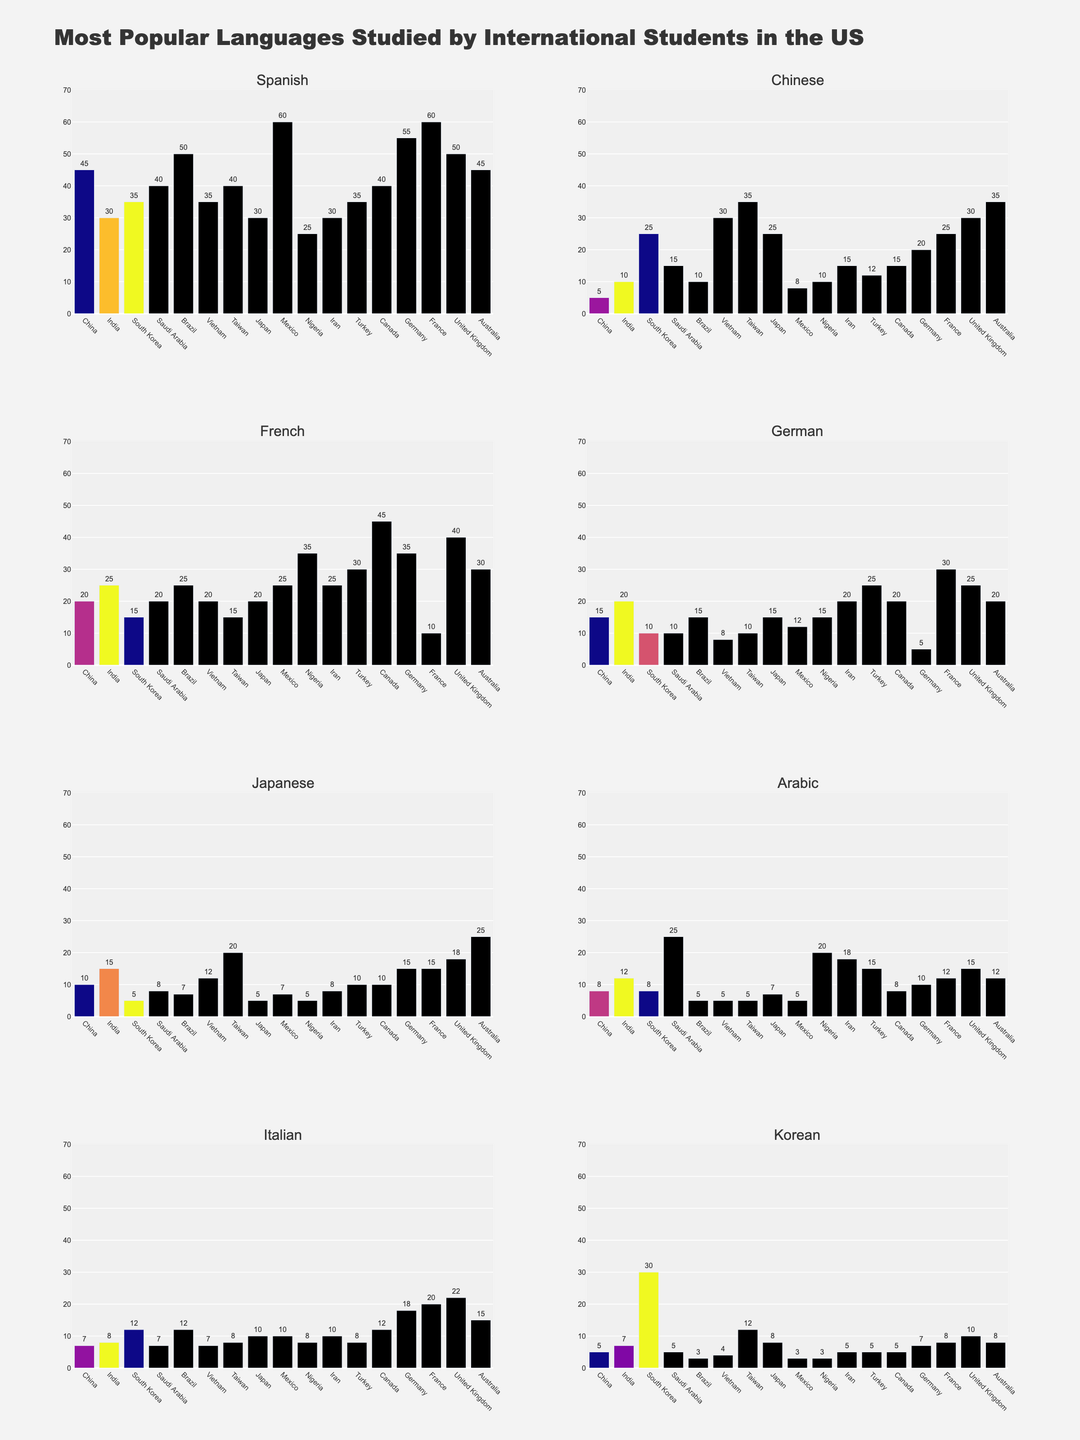Which country has the highest number of students studying Spanish? By comparing the heights of the bars in the Spanish subplot, we see that Mexico has the tallest bar.
Answer: Mexico How many more students in Taiwan study Chinese compared to Germany? Taiwan has 35 students studying Chinese, while Germany has 20. The difference is 35 - 20 = 15.
Answer: 15 Which country has the lowest number of students studying Italian? By comparing all the bars in the Italian subplot, we see that Vietnam and Mexico have the shortest bars, both with 7 students.
Answer: Vietnam, Mexico What is the total number of students studying French in Brazil, Iran, and Canada combined? Summing the French students in these countries gives us 25 (Brazil) + 25 (Iran) + 45 (Canada) = 95.
Answer: 95 Are there more students studying Arabic in Saudi Arabia or Chinese in South Korea? Saudi Arabia has 25 students studying Arabic, while South Korea has 25 students studying Chinese, so they are equal.
Answer: equal Which language has the most students studying it in Japan? By examining the height of the bars in all plots for Japan, we see that English has 30 students, which is the highest.
Answer: English What's the difference between the highest and lowest number of students studying Japanese? The highest is 25 (in Australia), and the lowest is 5 (in China and Turkey), so the difference is 25 - 5 = 20.
Answer: 20 Which two languages have the closest number of students studying them in France? Looking at the bars, Italian and Arabic have 20 and 18 students respectively, making the difference 2, the smallest among all comparisons.
Answer: Italian and Arabic 